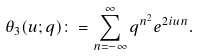<formula> <loc_0><loc_0><loc_500><loc_500>\theta _ { 3 } ( u ; q ) \colon = \sum _ { n = - \infty } ^ { \infty } q ^ { n ^ { 2 } } e ^ { 2 i u n } .</formula> 